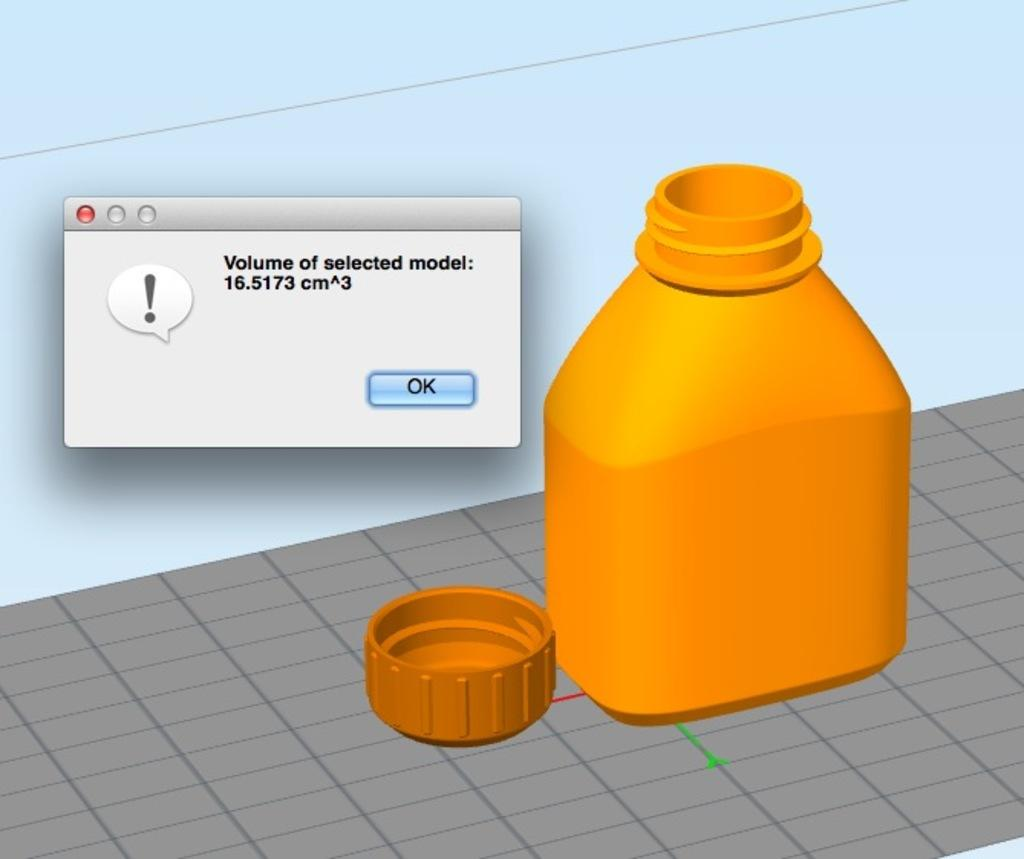<image>
Describe the image concisely. A plastic liquid container with a screenshot that states: "Volume of selected model: 16.5173 cm>3". 